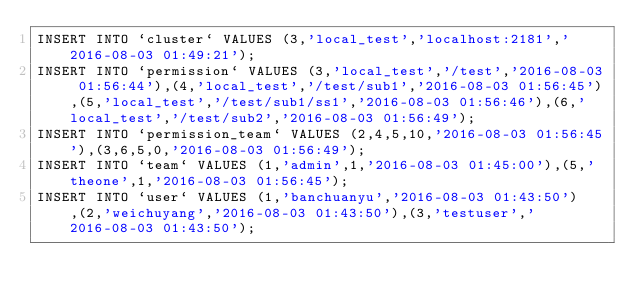Convert code to text. <code><loc_0><loc_0><loc_500><loc_500><_SQL_>INSERT INTO `cluster` VALUES (3,'local_test','localhost:2181','2016-08-03 01:49:21');
INSERT INTO `permission` VALUES (3,'local_test','/test','2016-08-03 01:56:44'),(4,'local_test','/test/sub1','2016-08-03 01:56:45'),(5,'local_test','/test/sub1/ss1','2016-08-03 01:56:46'),(6,'local_test','/test/sub2','2016-08-03 01:56:49');
INSERT INTO `permission_team` VALUES (2,4,5,10,'2016-08-03 01:56:45'),(3,6,5,0,'2016-08-03 01:56:49');
INSERT INTO `team` VALUES (1,'admin',1,'2016-08-03 01:45:00'),(5,'theone',1,'2016-08-03 01:56:45');
INSERT INTO `user` VALUES (1,'banchuanyu','2016-08-03 01:43:50'),(2,'weichuyang','2016-08-03 01:43:50'),(3,'testuser','2016-08-03 01:43:50');</code> 